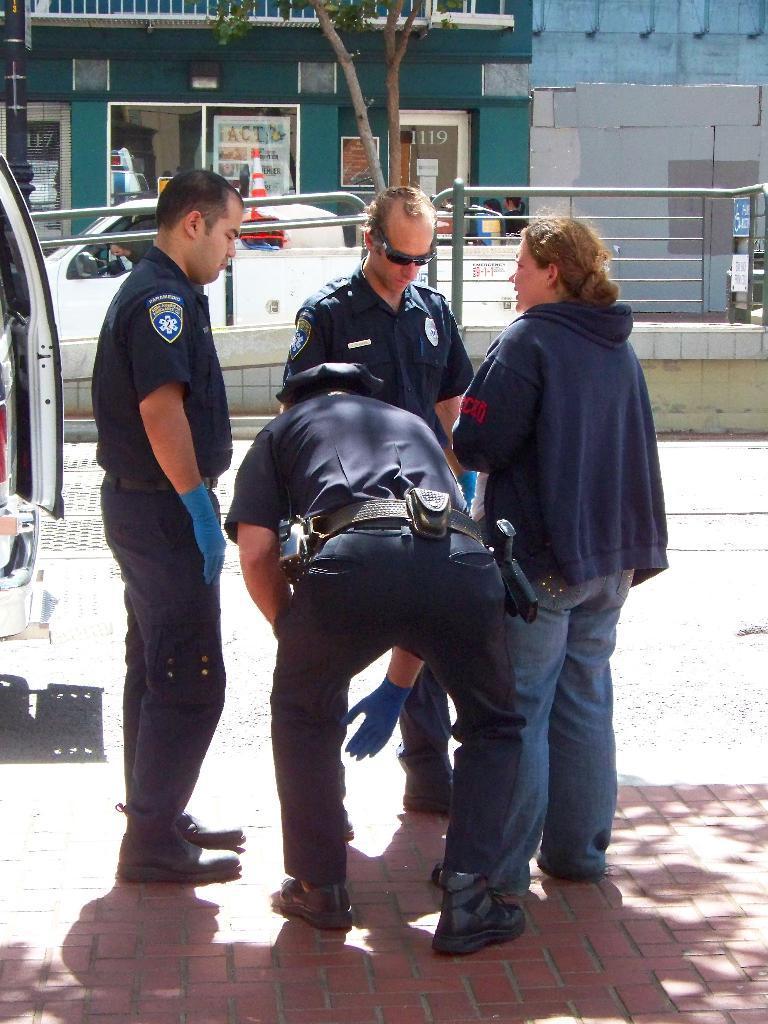In one or two sentences, can you explain what this image depicts? In this image, there are four persons standing. In the background, there are buildings, tree, vehicle and iron grilles. 